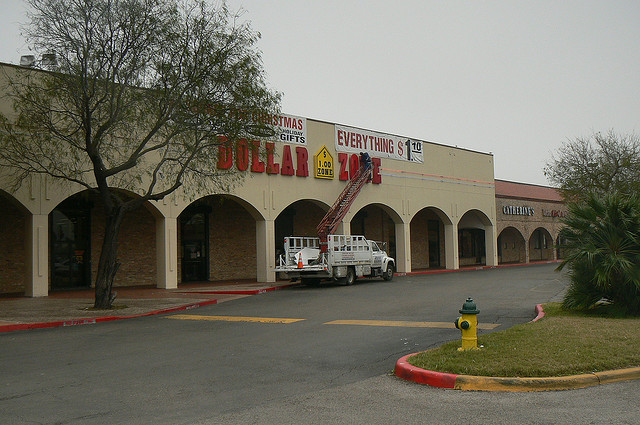Please transcribe the text in this image. GIFTS DOLLAR EVERYTHING 110 ZONE 